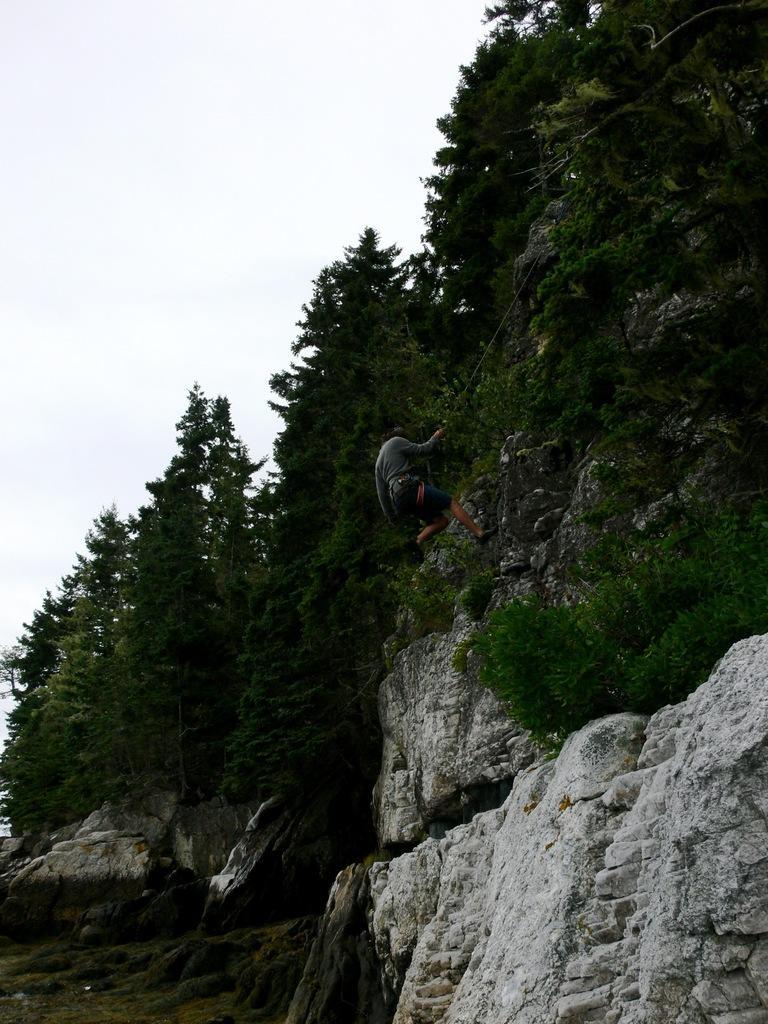In one or two sentences, can you explain what this image depicts? In this image in the center there is a man climbing and there are trees. On the ground there is grass and the sky is cloudy. 